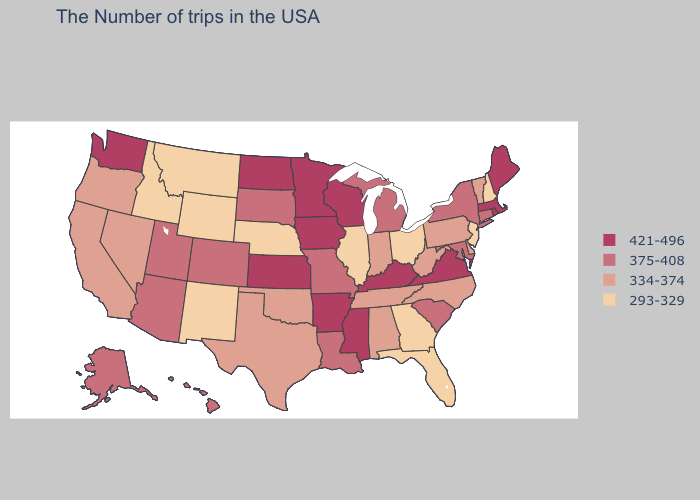Does the map have missing data?
Keep it brief. No. Does Minnesota have the same value as Vermont?
Concise answer only. No. Which states hav the highest value in the South?
Concise answer only. Virginia, Kentucky, Mississippi, Arkansas. Does Illinois have the lowest value in the MidWest?
Concise answer only. Yes. Which states have the lowest value in the USA?
Write a very short answer. New Hampshire, New Jersey, Ohio, Florida, Georgia, Illinois, Nebraska, Wyoming, New Mexico, Montana, Idaho. Does the map have missing data?
Write a very short answer. No. Does the map have missing data?
Give a very brief answer. No. Name the states that have a value in the range 375-408?
Write a very short answer. Connecticut, New York, Maryland, South Carolina, Michigan, Louisiana, Missouri, South Dakota, Colorado, Utah, Arizona, Alaska, Hawaii. Which states hav the highest value in the Northeast?
Short answer required. Maine, Massachusetts, Rhode Island. Name the states that have a value in the range 334-374?
Be succinct. Vermont, Delaware, Pennsylvania, North Carolina, West Virginia, Indiana, Alabama, Tennessee, Oklahoma, Texas, Nevada, California, Oregon. Name the states that have a value in the range 421-496?
Answer briefly. Maine, Massachusetts, Rhode Island, Virginia, Kentucky, Wisconsin, Mississippi, Arkansas, Minnesota, Iowa, Kansas, North Dakota, Washington. Does California have the highest value in the USA?
Quick response, please. No. What is the value of Massachusetts?
Write a very short answer. 421-496. Does Rhode Island have the same value as Kansas?
Give a very brief answer. Yes. What is the value of Rhode Island?
Be succinct. 421-496. 